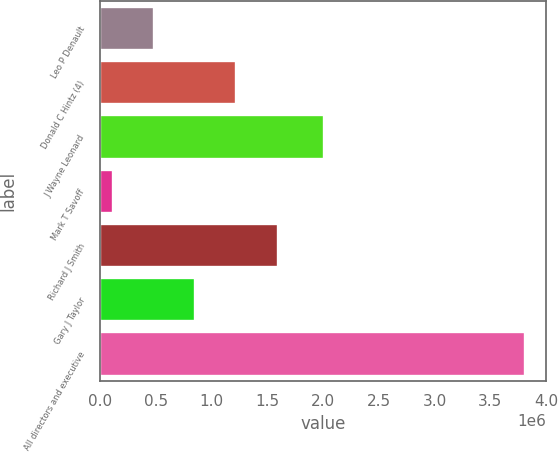Convert chart to OTSL. <chart><loc_0><loc_0><loc_500><loc_500><bar_chart><fcel>Leo P Denault<fcel>Donald C Hintz (4)<fcel>J Wayne Leonard<fcel>Mark T Savoff<fcel>Richard J Smith<fcel>Gary J Taylor<fcel>All directors and executive<nl><fcel>483843<fcel>1.22326e+06<fcel>2.01033e+06<fcel>114133<fcel>1.59297e+06<fcel>853553<fcel>3.81123e+06<nl></chart> 